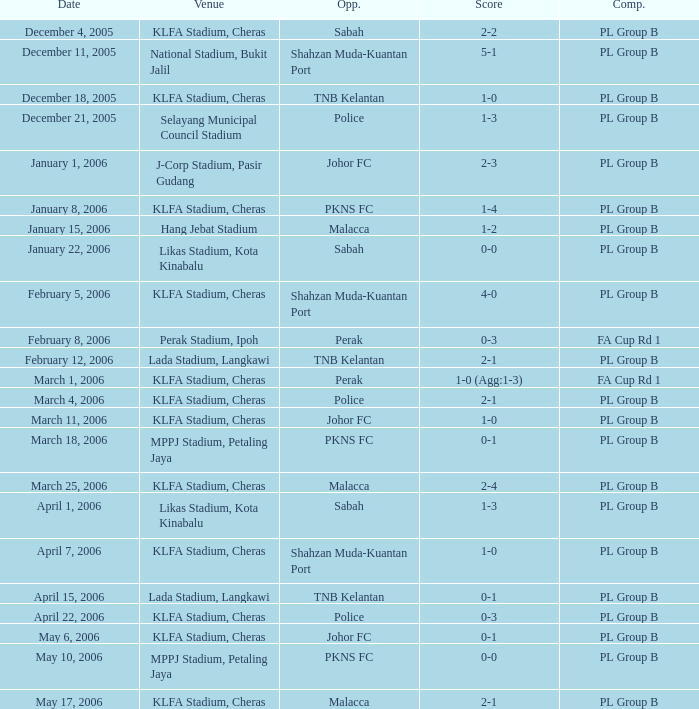Which Score has Opponents of pkns fc, and a Date of january 8, 2006? 1-4. 